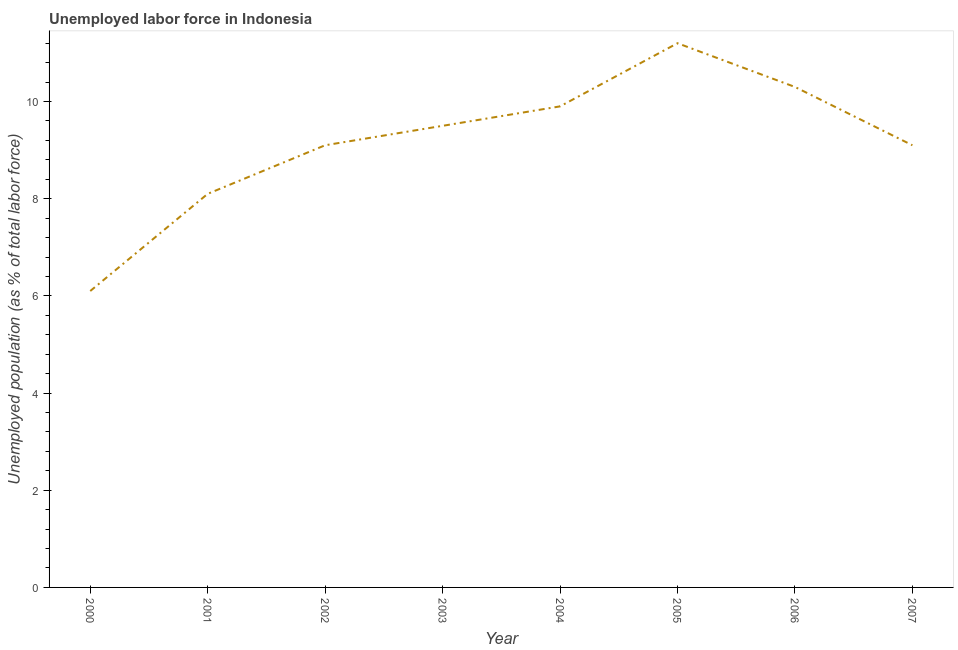What is the total unemployed population in 2000?
Your answer should be very brief. 6.1. Across all years, what is the maximum total unemployed population?
Offer a very short reply. 11.2. Across all years, what is the minimum total unemployed population?
Ensure brevity in your answer.  6.1. In which year was the total unemployed population maximum?
Ensure brevity in your answer.  2005. What is the sum of the total unemployed population?
Your response must be concise. 73.3. What is the difference between the total unemployed population in 2001 and 2003?
Offer a terse response. -1.4. What is the average total unemployed population per year?
Keep it short and to the point. 9.16. What is the median total unemployed population?
Ensure brevity in your answer.  9.3. In how many years, is the total unemployed population greater than 0.8 %?
Provide a succinct answer. 8. Do a majority of the years between 2002 and 2005 (inclusive) have total unemployed population greater than 2.8 %?
Your answer should be compact. Yes. What is the ratio of the total unemployed population in 2000 to that in 2003?
Your answer should be very brief. 0.64. What is the difference between the highest and the second highest total unemployed population?
Offer a terse response. 0.9. Is the sum of the total unemployed population in 2001 and 2004 greater than the maximum total unemployed population across all years?
Give a very brief answer. Yes. What is the difference between the highest and the lowest total unemployed population?
Provide a short and direct response. 5.1. In how many years, is the total unemployed population greater than the average total unemployed population taken over all years?
Offer a terse response. 4. How many years are there in the graph?
Provide a short and direct response. 8. What is the difference between two consecutive major ticks on the Y-axis?
Offer a terse response. 2. Does the graph contain any zero values?
Give a very brief answer. No. What is the title of the graph?
Make the answer very short. Unemployed labor force in Indonesia. What is the label or title of the Y-axis?
Provide a succinct answer. Unemployed population (as % of total labor force). What is the Unemployed population (as % of total labor force) in 2000?
Provide a succinct answer. 6.1. What is the Unemployed population (as % of total labor force) in 2001?
Provide a succinct answer. 8.1. What is the Unemployed population (as % of total labor force) in 2002?
Ensure brevity in your answer.  9.1. What is the Unemployed population (as % of total labor force) in 2004?
Give a very brief answer. 9.9. What is the Unemployed population (as % of total labor force) in 2005?
Give a very brief answer. 11.2. What is the Unemployed population (as % of total labor force) in 2006?
Your response must be concise. 10.3. What is the Unemployed population (as % of total labor force) in 2007?
Give a very brief answer. 9.1. What is the difference between the Unemployed population (as % of total labor force) in 2000 and 2005?
Provide a short and direct response. -5.1. What is the difference between the Unemployed population (as % of total labor force) in 2000 and 2007?
Make the answer very short. -3. What is the difference between the Unemployed population (as % of total labor force) in 2001 and 2003?
Your response must be concise. -1.4. What is the difference between the Unemployed population (as % of total labor force) in 2001 and 2004?
Provide a short and direct response. -1.8. What is the difference between the Unemployed population (as % of total labor force) in 2001 and 2005?
Give a very brief answer. -3.1. What is the difference between the Unemployed population (as % of total labor force) in 2001 and 2006?
Your answer should be compact. -2.2. What is the difference between the Unemployed population (as % of total labor force) in 2002 and 2003?
Keep it short and to the point. -0.4. What is the difference between the Unemployed population (as % of total labor force) in 2002 and 2005?
Make the answer very short. -2.1. What is the difference between the Unemployed population (as % of total labor force) in 2002 and 2006?
Your answer should be compact. -1.2. What is the difference between the Unemployed population (as % of total labor force) in 2003 and 2004?
Ensure brevity in your answer.  -0.4. What is the difference between the Unemployed population (as % of total labor force) in 2003 and 2006?
Offer a terse response. -0.8. What is the difference between the Unemployed population (as % of total labor force) in 2004 and 2006?
Your response must be concise. -0.4. What is the difference between the Unemployed population (as % of total labor force) in 2005 and 2007?
Your answer should be compact. 2.1. What is the difference between the Unemployed population (as % of total labor force) in 2006 and 2007?
Provide a succinct answer. 1.2. What is the ratio of the Unemployed population (as % of total labor force) in 2000 to that in 2001?
Provide a succinct answer. 0.75. What is the ratio of the Unemployed population (as % of total labor force) in 2000 to that in 2002?
Your answer should be compact. 0.67. What is the ratio of the Unemployed population (as % of total labor force) in 2000 to that in 2003?
Provide a short and direct response. 0.64. What is the ratio of the Unemployed population (as % of total labor force) in 2000 to that in 2004?
Offer a very short reply. 0.62. What is the ratio of the Unemployed population (as % of total labor force) in 2000 to that in 2005?
Give a very brief answer. 0.55. What is the ratio of the Unemployed population (as % of total labor force) in 2000 to that in 2006?
Make the answer very short. 0.59. What is the ratio of the Unemployed population (as % of total labor force) in 2000 to that in 2007?
Your response must be concise. 0.67. What is the ratio of the Unemployed population (as % of total labor force) in 2001 to that in 2002?
Your response must be concise. 0.89. What is the ratio of the Unemployed population (as % of total labor force) in 2001 to that in 2003?
Ensure brevity in your answer.  0.85. What is the ratio of the Unemployed population (as % of total labor force) in 2001 to that in 2004?
Provide a succinct answer. 0.82. What is the ratio of the Unemployed population (as % of total labor force) in 2001 to that in 2005?
Your response must be concise. 0.72. What is the ratio of the Unemployed population (as % of total labor force) in 2001 to that in 2006?
Provide a succinct answer. 0.79. What is the ratio of the Unemployed population (as % of total labor force) in 2001 to that in 2007?
Your response must be concise. 0.89. What is the ratio of the Unemployed population (as % of total labor force) in 2002 to that in 2003?
Your answer should be compact. 0.96. What is the ratio of the Unemployed population (as % of total labor force) in 2002 to that in 2004?
Keep it short and to the point. 0.92. What is the ratio of the Unemployed population (as % of total labor force) in 2002 to that in 2005?
Make the answer very short. 0.81. What is the ratio of the Unemployed population (as % of total labor force) in 2002 to that in 2006?
Provide a short and direct response. 0.88. What is the ratio of the Unemployed population (as % of total labor force) in 2003 to that in 2005?
Give a very brief answer. 0.85. What is the ratio of the Unemployed population (as % of total labor force) in 2003 to that in 2006?
Ensure brevity in your answer.  0.92. What is the ratio of the Unemployed population (as % of total labor force) in 2003 to that in 2007?
Offer a very short reply. 1.04. What is the ratio of the Unemployed population (as % of total labor force) in 2004 to that in 2005?
Provide a short and direct response. 0.88. What is the ratio of the Unemployed population (as % of total labor force) in 2004 to that in 2007?
Your response must be concise. 1.09. What is the ratio of the Unemployed population (as % of total labor force) in 2005 to that in 2006?
Give a very brief answer. 1.09. What is the ratio of the Unemployed population (as % of total labor force) in 2005 to that in 2007?
Offer a very short reply. 1.23. What is the ratio of the Unemployed population (as % of total labor force) in 2006 to that in 2007?
Your response must be concise. 1.13. 